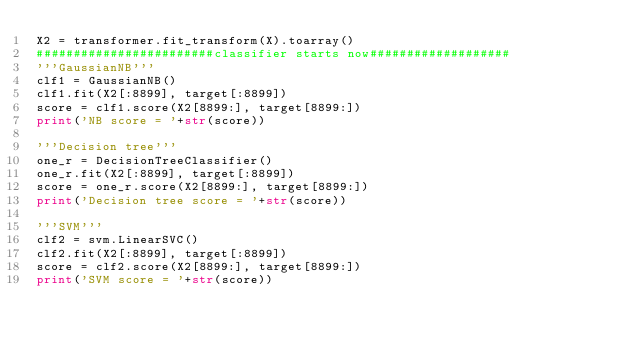<code> <loc_0><loc_0><loc_500><loc_500><_Python_>X2 = transformer.fit_transform(X).toarray()
########################classifier starts now###################
'''GaussianNB'''
clf1 = GaussianNB()
clf1.fit(X2[:8899], target[:8899])
score = clf1.score(X2[8899:], target[8899:])
print('NB score = '+str(score))

'''Decision tree'''
one_r = DecisionTreeClassifier()
one_r.fit(X2[:8899], target[:8899])
score = one_r.score(X2[8899:], target[8899:])
print('Decision tree score = '+str(score))

'''SVM'''
clf2 = svm.LinearSVC()
clf2.fit(X2[:8899], target[:8899])
score = clf2.score(X2[8899:], target[8899:])
print('SVM score = '+str(score))

</code> 